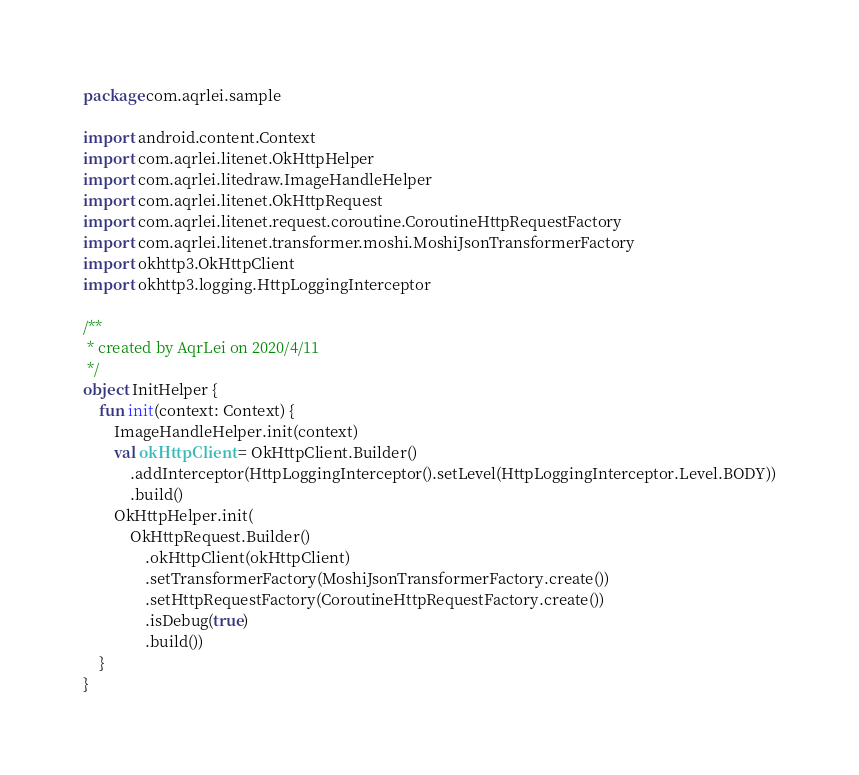<code> <loc_0><loc_0><loc_500><loc_500><_Kotlin_>package com.aqrlei.sample

import android.content.Context
import com.aqrlei.litenet.OkHttpHelper
import com.aqrlei.litedraw.ImageHandleHelper
import com.aqrlei.litenet.OkHttpRequest
import com.aqrlei.litenet.request.coroutine.CoroutineHttpRequestFactory
import com.aqrlei.litenet.transformer.moshi.MoshiJsonTransformerFactory
import okhttp3.OkHttpClient
import okhttp3.logging.HttpLoggingInterceptor

/**
 * created by AqrLei on 2020/4/11
 */
object InitHelper {
    fun init(context: Context) {
        ImageHandleHelper.init(context)
        val okHttpClient = OkHttpClient.Builder()
            .addInterceptor(HttpLoggingInterceptor().setLevel(HttpLoggingInterceptor.Level.BODY))
            .build()
        OkHttpHelper.init(
            OkHttpRequest.Builder()
                .okHttpClient(okHttpClient)
                .setTransformerFactory(MoshiJsonTransformerFactory.create())
                .setHttpRequestFactory(CoroutineHttpRequestFactory.create())
                .isDebug(true)
                .build())
    }
}</code> 